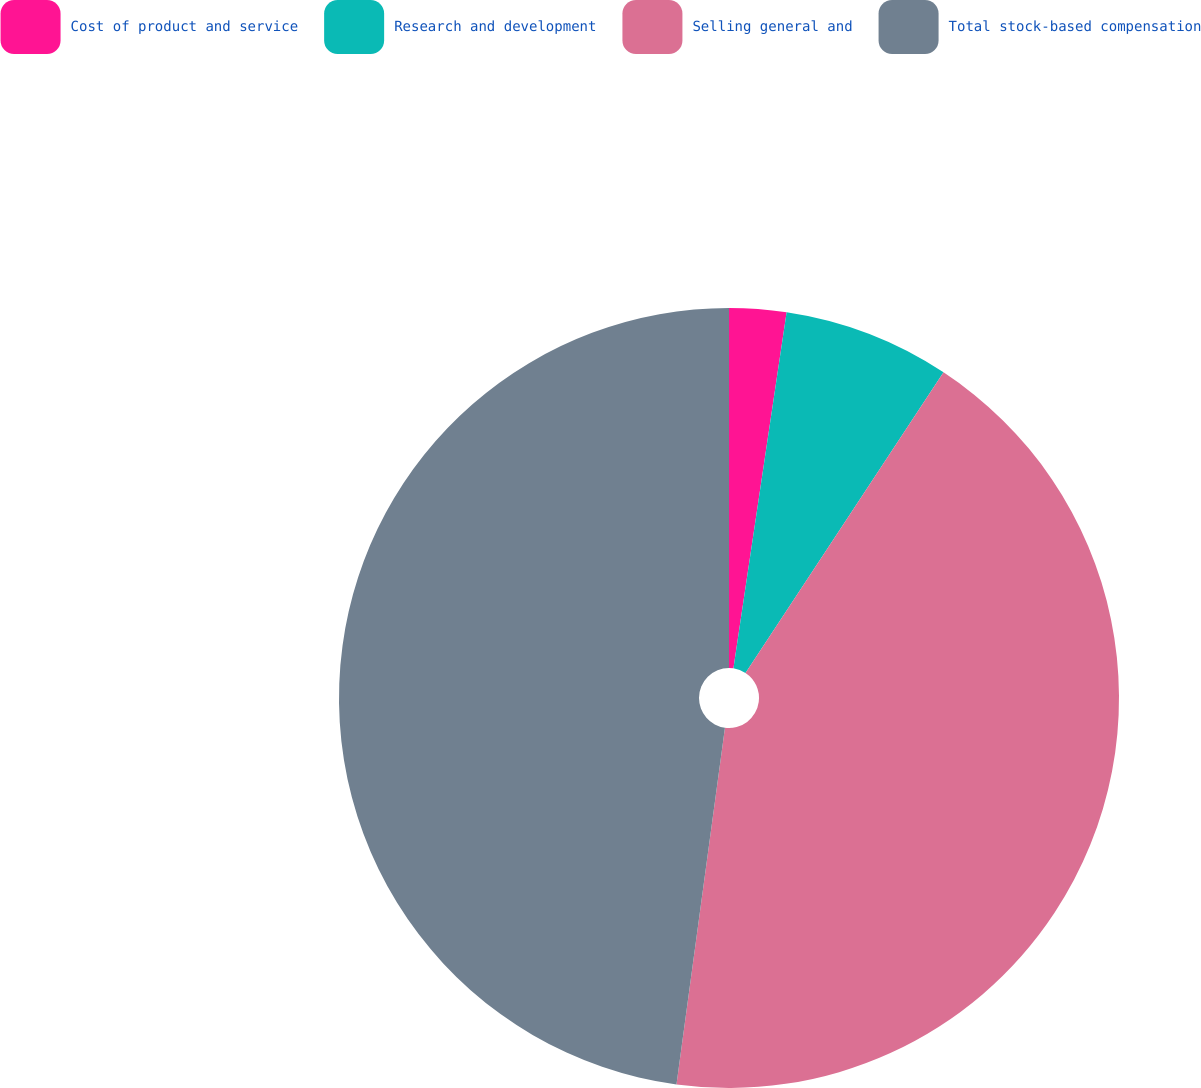<chart> <loc_0><loc_0><loc_500><loc_500><pie_chart><fcel>Cost of product and service<fcel>Research and development<fcel>Selling general and<fcel>Total stock-based compensation<nl><fcel>2.36%<fcel>6.91%<fcel>42.88%<fcel>47.85%<nl></chart> 